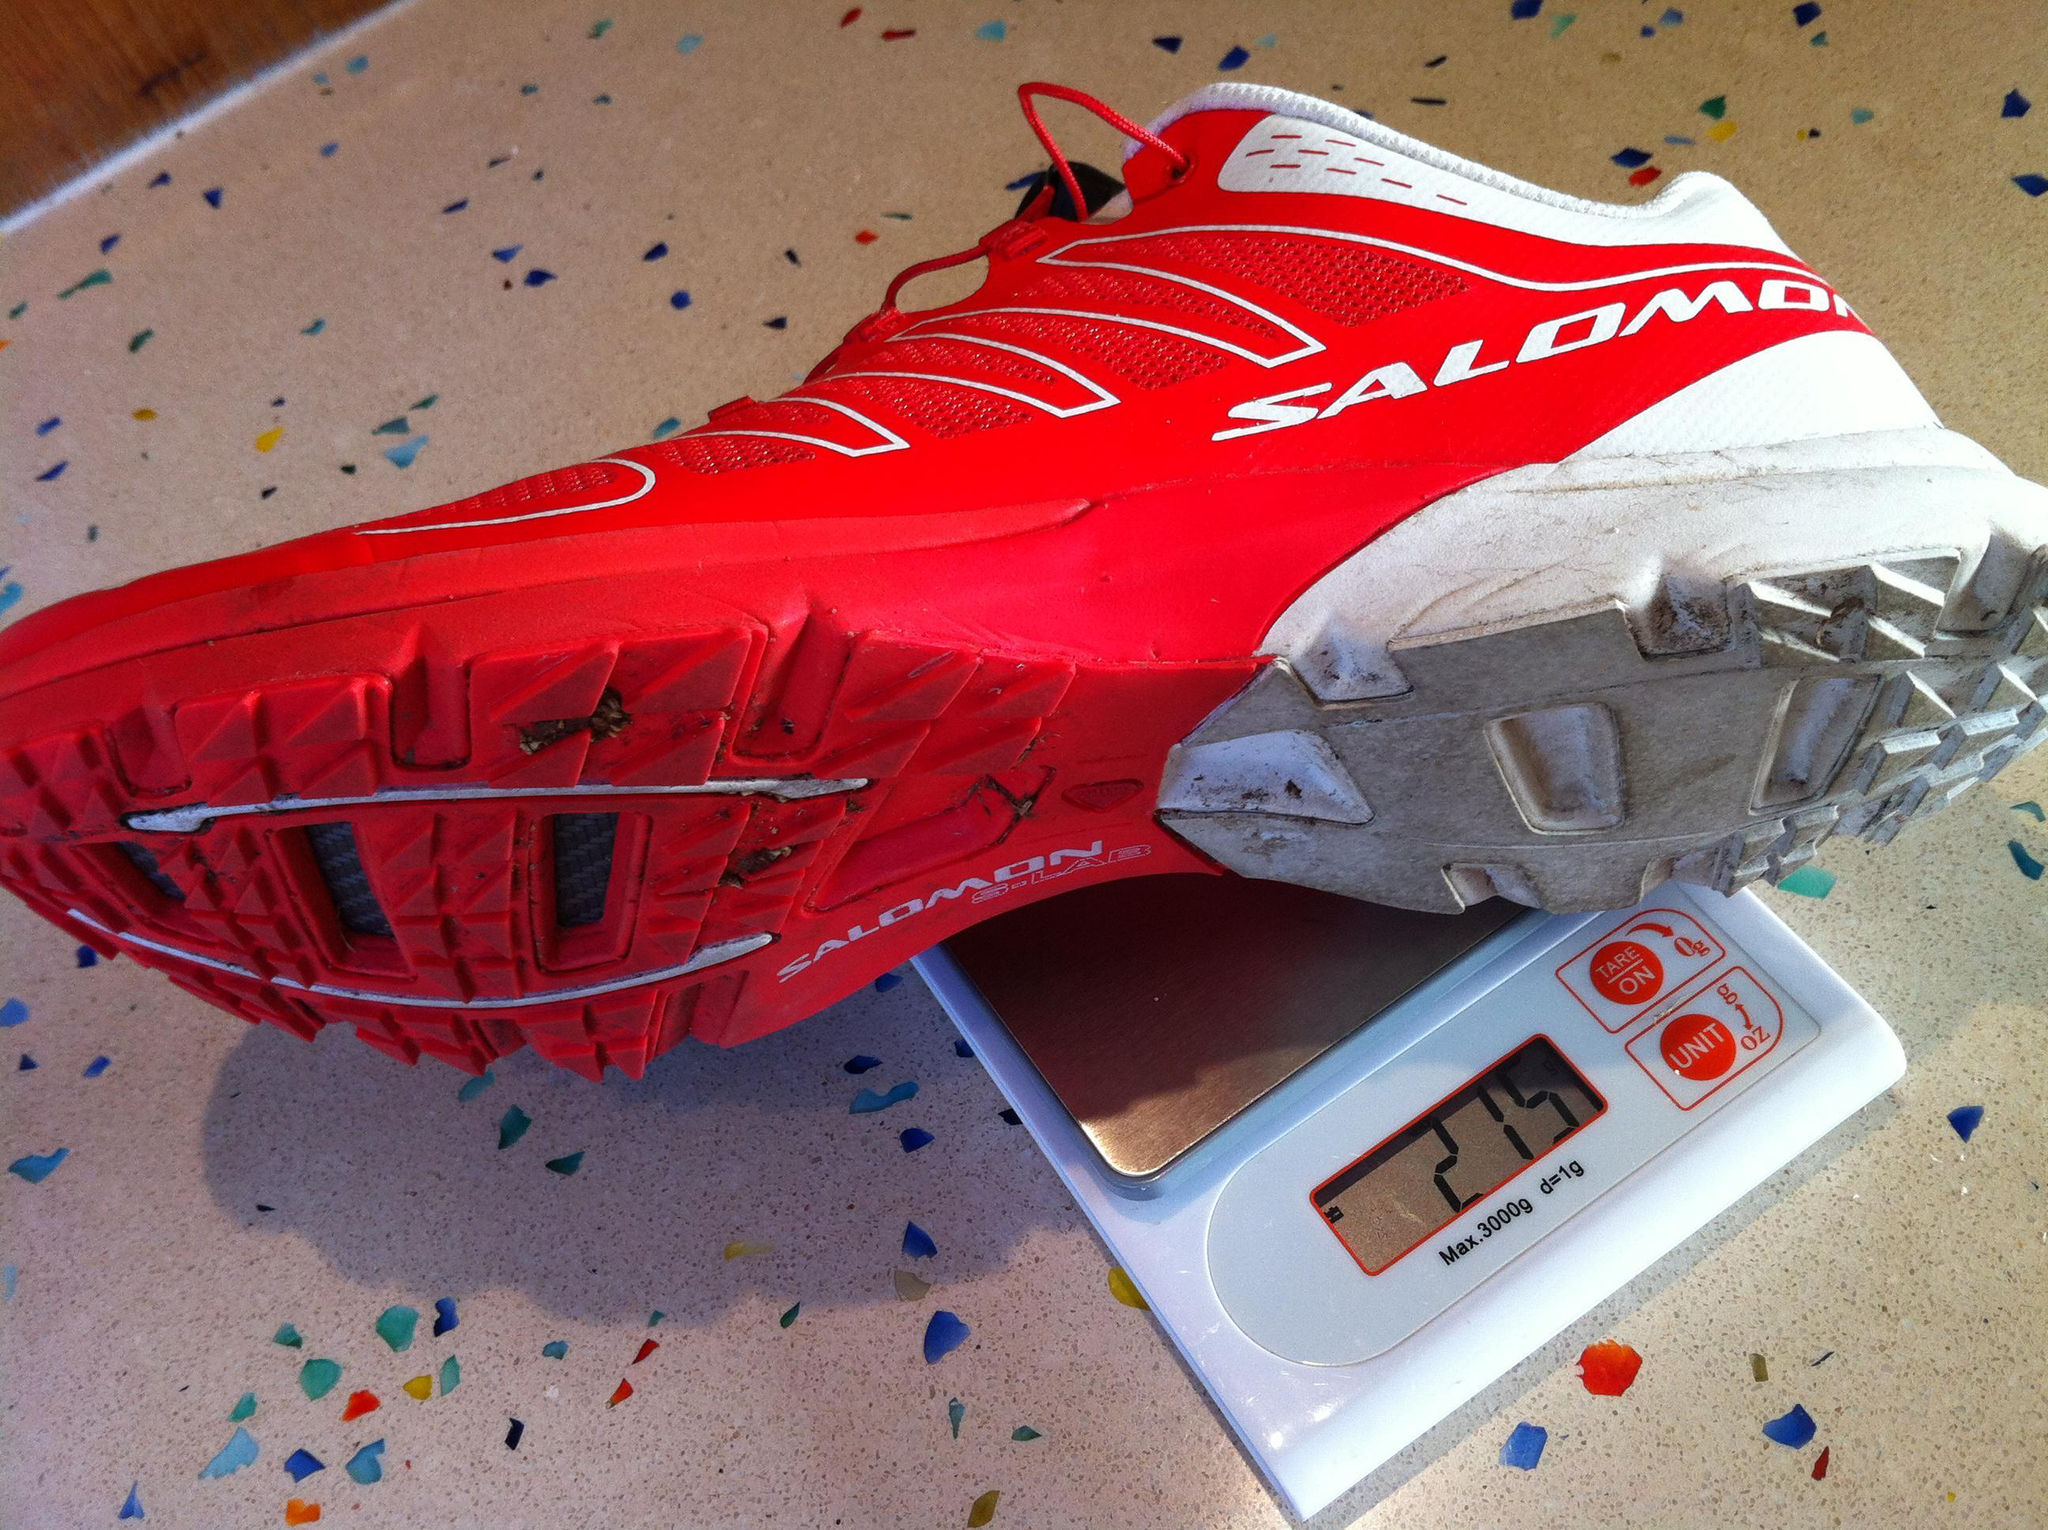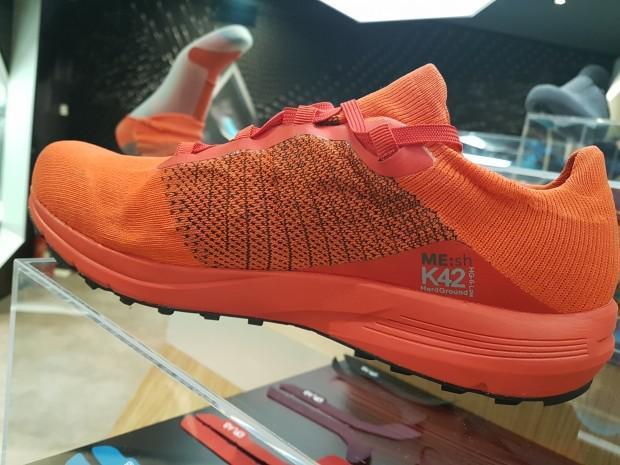The first image is the image on the left, the second image is the image on the right. For the images displayed, is the sentence "Each image contains one sneaker that includes red color, and the shoes in the left and right images face different directions." factually correct? Answer yes or no. No. The first image is the image on the left, the second image is the image on the right. Given the left and right images, does the statement "All of the shoes in the images are being displayed indoors." hold true? Answer yes or no. Yes. 